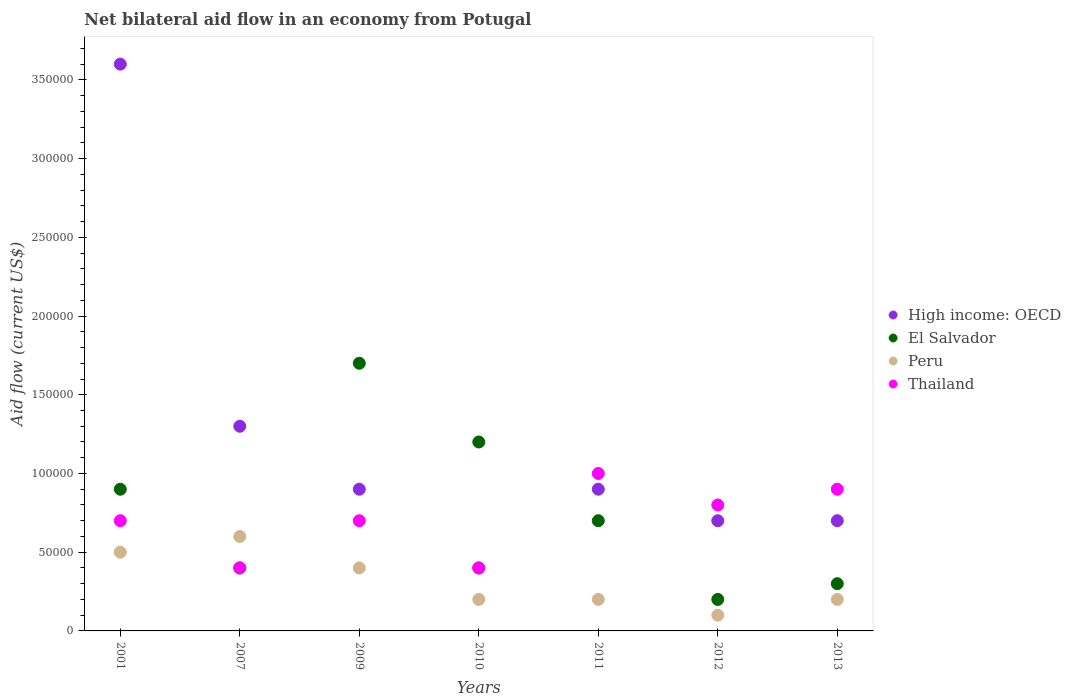How many different coloured dotlines are there?
Ensure brevity in your answer.  4. Is the number of dotlines equal to the number of legend labels?
Provide a succinct answer. Yes. In which year was the net bilateral aid flow in Thailand maximum?
Ensure brevity in your answer.  2011. What is the total net bilateral aid flow in Thailand in the graph?
Give a very brief answer. 4.90e+05. What is the difference between the net bilateral aid flow in El Salvador in 2011 and that in 2012?
Your response must be concise. 5.00e+04. What is the difference between the net bilateral aid flow in El Salvador in 2010 and the net bilateral aid flow in Thailand in 2007?
Your answer should be compact. 8.00e+04. What is the average net bilateral aid flow in Peru per year?
Ensure brevity in your answer.  3.14e+04. In the year 2013, what is the difference between the net bilateral aid flow in High income: OECD and net bilateral aid flow in Peru?
Provide a succinct answer. 5.00e+04. In how many years, is the net bilateral aid flow in El Salvador greater than the average net bilateral aid flow in El Salvador taken over all years?
Ensure brevity in your answer.  3. Does the net bilateral aid flow in El Salvador monotonically increase over the years?
Keep it short and to the point. No. Is the net bilateral aid flow in El Salvador strictly less than the net bilateral aid flow in Thailand over the years?
Offer a very short reply. No. How many years are there in the graph?
Provide a succinct answer. 7. Does the graph contain grids?
Your answer should be compact. No. Where does the legend appear in the graph?
Your answer should be very brief. Center right. What is the title of the graph?
Your answer should be compact. Net bilateral aid flow in an economy from Potugal. What is the label or title of the X-axis?
Give a very brief answer. Years. What is the Aid flow (current US$) of High income: OECD in 2001?
Provide a succinct answer. 3.60e+05. What is the Aid flow (current US$) of El Salvador in 2001?
Give a very brief answer. 9.00e+04. What is the Aid flow (current US$) of Thailand in 2001?
Your answer should be compact. 7.00e+04. What is the Aid flow (current US$) in El Salvador in 2007?
Ensure brevity in your answer.  4.00e+04. What is the Aid flow (current US$) of Thailand in 2007?
Offer a very short reply. 4.00e+04. What is the Aid flow (current US$) of Peru in 2009?
Your answer should be very brief. 4.00e+04. What is the Aid flow (current US$) of Thailand in 2010?
Your response must be concise. 4.00e+04. What is the Aid flow (current US$) in High income: OECD in 2011?
Make the answer very short. 9.00e+04. What is the Aid flow (current US$) in High income: OECD in 2012?
Ensure brevity in your answer.  7.00e+04. What is the Aid flow (current US$) in El Salvador in 2012?
Offer a very short reply. 2.00e+04. What is the Aid flow (current US$) of Peru in 2012?
Offer a very short reply. 10000. What is the Aid flow (current US$) in Thailand in 2012?
Offer a very short reply. 8.00e+04. What is the Aid flow (current US$) of High income: OECD in 2013?
Your answer should be very brief. 7.00e+04. What is the Aid flow (current US$) in Thailand in 2013?
Ensure brevity in your answer.  9.00e+04. Across all years, what is the maximum Aid flow (current US$) in High income: OECD?
Your answer should be very brief. 3.60e+05. Across all years, what is the minimum Aid flow (current US$) of El Salvador?
Offer a very short reply. 2.00e+04. Across all years, what is the minimum Aid flow (current US$) of Thailand?
Your answer should be very brief. 4.00e+04. What is the total Aid flow (current US$) in High income: OECD in the graph?
Ensure brevity in your answer.  8.50e+05. What is the total Aid flow (current US$) of El Salvador in the graph?
Your answer should be compact. 5.40e+05. What is the total Aid flow (current US$) in Thailand in the graph?
Your answer should be very brief. 4.90e+05. What is the difference between the Aid flow (current US$) in High income: OECD in 2001 and that in 2007?
Offer a very short reply. 2.30e+05. What is the difference between the Aid flow (current US$) in El Salvador in 2001 and that in 2007?
Your response must be concise. 5.00e+04. What is the difference between the Aid flow (current US$) of Thailand in 2001 and that in 2007?
Offer a very short reply. 3.00e+04. What is the difference between the Aid flow (current US$) of El Salvador in 2001 and that in 2009?
Offer a very short reply. -8.00e+04. What is the difference between the Aid flow (current US$) of El Salvador in 2001 and that in 2010?
Your answer should be very brief. -3.00e+04. What is the difference between the Aid flow (current US$) in Thailand in 2001 and that in 2010?
Make the answer very short. 3.00e+04. What is the difference between the Aid flow (current US$) in El Salvador in 2001 and that in 2011?
Ensure brevity in your answer.  2.00e+04. What is the difference between the Aid flow (current US$) in Peru in 2001 and that in 2011?
Make the answer very short. 3.00e+04. What is the difference between the Aid flow (current US$) in Thailand in 2001 and that in 2011?
Your answer should be compact. -3.00e+04. What is the difference between the Aid flow (current US$) of El Salvador in 2001 and that in 2012?
Offer a terse response. 7.00e+04. What is the difference between the Aid flow (current US$) of Thailand in 2001 and that in 2012?
Your response must be concise. -10000. What is the difference between the Aid flow (current US$) in High income: OECD in 2001 and that in 2013?
Keep it short and to the point. 2.90e+05. What is the difference between the Aid flow (current US$) of Thailand in 2001 and that in 2013?
Provide a short and direct response. -2.00e+04. What is the difference between the Aid flow (current US$) of High income: OECD in 2007 and that in 2009?
Ensure brevity in your answer.  4.00e+04. What is the difference between the Aid flow (current US$) of Peru in 2007 and that in 2009?
Your answer should be compact. 2.00e+04. What is the difference between the Aid flow (current US$) of El Salvador in 2007 and that in 2010?
Offer a terse response. -8.00e+04. What is the difference between the Aid flow (current US$) in Peru in 2007 and that in 2010?
Your answer should be very brief. 4.00e+04. What is the difference between the Aid flow (current US$) of High income: OECD in 2007 and that in 2011?
Your answer should be compact. 4.00e+04. What is the difference between the Aid flow (current US$) in Peru in 2007 and that in 2011?
Offer a terse response. 4.00e+04. What is the difference between the Aid flow (current US$) in High income: OECD in 2007 and that in 2012?
Make the answer very short. 6.00e+04. What is the difference between the Aid flow (current US$) in Thailand in 2007 and that in 2012?
Keep it short and to the point. -4.00e+04. What is the difference between the Aid flow (current US$) of High income: OECD in 2007 and that in 2013?
Your answer should be very brief. 6.00e+04. What is the difference between the Aid flow (current US$) in El Salvador in 2007 and that in 2013?
Ensure brevity in your answer.  10000. What is the difference between the Aid flow (current US$) in Thailand in 2007 and that in 2013?
Ensure brevity in your answer.  -5.00e+04. What is the difference between the Aid flow (current US$) of El Salvador in 2009 and that in 2010?
Provide a short and direct response. 5.00e+04. What is the difference between the Aid flow (current US$) in High income: OECD in 2009 and that in 2011?
Offer a terse response. 0. What is the difference between the Aid flow (current US$) in High income: OECD in 2009 and that in 2012?
Your answer should be very brief. 2.00e+04. What is the difference between the Aid flow (current US$) of El Salvador in 2009 and that in 2012?
Your response must be concise. 1.50e+05. What is the difference between the Aid flow (current US$) in Thailand in 2009 and that in 2012?
Make the answer very short. -10000. What is the difference between the Aid flow (current US$) of High income: OECD in 2009 and that in 2013?
Offer a very short reply. 2.00e+04. What is the difference between the Aid flow (current US$) of Peru in 2009 and that in 2013?
Offer a very short reply. 2.00e+04. What is the difference between the Aid flow (current US$) in High income: OECD in 2010 and that in 2011?
Your answer should be very brief. -5.00e+04. What is the difference between the Aid flow (current US$) of Thailand in 2010 and that in 2011?
Your answer should be very brief. -6.00e+04. What is the difference between the Aid flow (current US$) in High income: OECD in 2010 and that in 2012?
Your answer should be very brief. -3.00e+04. What is the difference between the Aid flow (current US$) of El Salvador in 2010 and that in 2012?
Give a very brief answer. 1.00e+05. What is the difference between the Aid flow (current US$) in Peru in 2010 and that in 2012?
Offer a terse response. 10000. What is the difference between the Aid flow (current US$) in Thailand in 2010 and that in 2012?
Give a very brief answer. -4.00e+04. What is the difference between the Aid flow (current US$) of High income: OECD in 2010 and that in 2013?
Keep it short and to the point. -3.00e+04. What is the difference between the Aid flow (current US$) of Thailand in 2010 and that in 2013?
Provide a succinct answer. -5.00e+04. What is the difference between the Aid flow (current US$) in High income: OECD in 2011 and that in 2012?
Provide a succinct answer. 2.00e+04. What is the difference between the Aid flow (current US$) in Peru in 2011 and that in 2012?
Provide a short and direct response. 10000. What is the difference between the Aid flow (current US$) of El Salvador in 2011 and that in 2013?
Your answer should be compact. 4.00e+04. What is the difference between the Aid flow (current US$) of High income: OECD in 2012 and that in 2013?
Your answer should be very brief. 0. What is the difference between the Aid flow (current US$) in High income: OECD in 2001 and the Aid flow (current US$) in Peru in 2007?
Give a very brief answer. 3.00e+05. What is the difference between the Aid flow (current US$) of High income: OECD in 2001 and the Aid flow (current US$) of Thailand in 2007?
Make the answer very short. 3.20e+05. What is the difference between the Aid flow (current US$) in High income: OECD in 2001 and the Aid flow (current US$) in El Salvador in 2009?
Your answer should be compact. 1.90e+05. What is the difference between the Aid flow (current US$) in High income: OECD in 2001 and the Aid flow (current US$) in Thailand in 2009?
Give a very brief answer. 2.90e+05. What is the difference between the Aid flow (current US$) in El Salvador in 2001 and the Aid flow (current US$) in Peru in 2009?
Your answer should be compact. 5.00e+04. What is the difference between the Aid flow (current US$) in El Salvador in 2001 and the Aid flow (current US$) in Thailand in 2009?
Ensure brevity in your answer.  2.00e+04. What is the difference between the Aid flow (current US$) of Peru in 2001 and the Aid flow (current US$) of Thailand in 2009?
Offer a terse response. -2.00e+04. What is the difference between the Aid flow (current US$) of High income: OECD in 2001 and the Aid flow (current US$) of Thailand in 2010?
Ensure brevity in your answer.  3.20e+05. What is the difference between the Aid flow (current US$) of High income: OECD in 2001 and the Aid flow (current US$) of El Salvador in 2011?
Make the answer very short. 2.90e+05. What is the difference between the Aid flow (current US$) in High income: OECD in 2001 and the Aid flow (current US$) in Thailand in 2011?
Your answer should be compact. 2.60e+05. What is the difference between the Aid flow (current US$) in El Salvador in 2001 and the Aid flow (current US$) in Peru in 2011?
Provide a succinct answer. 7.00e+04. What is the difference between the Aid flow (current US$) of El Salvador in 2001 and the Aid flow (current US$) of Peru in 2012?
Your response must be concise. 8.00e+04. What is the difference between the Aid flow (current US$) in El Salvador in 2001 and the Aid flow (current US$) in Thailand in 2012?
Keep it short and to the point. 10000. What is the difference between the Aid flow (current US$) of High income: OECD in 2001 and the Aid flow (current US$) of Peru in 2013?
Keep it short and to the point. 3.40e+05. What is the difference between the Aid flow (current US$) of High income: OECD in 2001 and the Aid flow (current US$) of Thailand in 2013?
Keep it short and to the point. 2.70e+05. What is the difference between the Aid flow (current US$) of Peru in 2001 and the Aid flow (current US$) of Thailand in 2013?
Offer a terse response. -4.00e+04. What is the difference between the Aid flow (current US$) of High income: OECD in 2007 and the Aid flow (current US$) of Peru in 2009?
Offer a terse response. 9.00e+04. What is the difference between the Aid flow (current US$) in High income: OECD in 2007 and the Aid flow (current US$) in Thailand in 2009?
Offer a terse response. 6.00e+04. What is the difference between the Aid flow (current US$) in El Salvador in 2007 and the Aid flow (current US$) in Peru in 2009?
Ensure brevity in your answer.  0. What is the difference between the Aid flow (current US$) in High income: OECD in 2007 and the Aid flow (current US$) in El Salvador in 2010?
Your answer should be compact. 10000. What is the difference between the Aid flow (current US$) in El Salvador in 2007 and the Aid flow (current US$) in Thailand in 2010?
Provide a short and direct response. 0. What is the difference between the Aid flow (current US$) in Peru in 2007 and the Aid flow (current US$) in Thailand in 2010?
Provide a short and direct response. 2.00e+04. What is the difference between the Aid flow (current US$) in High income: OECD in 2007 and the Aid flow (current US$) in Peru in 2011?
Provide a succinct answer. 1.10e+05. What is the difference between the Aid flow (current US$) in El Salvador in 2007 and the Aid flow (current US$) in Peru in 2011?
Make the answer very short. 2.00e+04. What is the difference between the Aid flow (current US$) in El Salvador in 2007 and the Aid flow (current US$) in Thailand in 2011?
Ensure brevity in your answer.  -6.00e+04. What is the difference between the Aid flow (current US$) of High income: OECD in 2007 and the Aid flow (current US$) of Peru in 2012?
Keep it short and to the point. 1.20e+05. What is the difference between the Aid flow (current US$) in El Salvador in 2007 and the Aid flow (current US$) in Peru in 2012?
Keep it short and to the point. 3.00e+04. What is the difference between the Aid flow (current US$) of El Salvador in 2007 and the Aid flow (current US$) of Thailand in 2012?
Offer a terse response. -4.00e+04. What is the difference between the Aid flow (current US$) in Peru in 2007 and the Aid flow (current US$) in Thailand in 2012?
Offer a very short reply. -2.00e+04. What is the difference between the Aid flow (current US$) of High income: OECD in 2007 and the Aid flow (current US$) of Peru in 2013?
Keep it short and to the point. 1.10e+05. What is the difference between the Aid flow (current US$) of High income: OECD in 2007 and the Aid flow (current US$) of Thailand in 2013?
Offer a very short reply. 4.00e+04. What is the difference between the Aid flow (current US$) in Peru in 2007 and the Aid flow (current US$) in Thailand in 2013?
Your answer should be compact. -3.00e+04. What is the difference between the Aid flow (current US$) of High income: OECD in 2009 and the Aid flow (current US$) of Peru in 2010?
Offer a very short reply. 7.00e+04. What is the difference between the Aid flow (current US$) in El Salvador in 2009 and the Aid flow (current US$) in Peru in 2010?
Your response must be concise. 1.50e+05. What is the difference between the Aid flow (current US$) of High income: OECD in 2009 and the Aid flow (current US$) of El Salvador in 2011?
Make the answer very short. 2.00e+04. What is the difference between the Aid flow (current US$) of High income: OECD in 2009 and the Aid flow (current US$) of Thailand in 2011?
Offer a very short reply. -10000. What is the difference between the Aid flow (current US$) of El Salvador in 2009 and the Aid flow (current US$) of Thailand in 2011?
Offer a terse response. 7.00e+04. What is the difference between the Aid flow (current US$) of Peru in 2009 and the Aid flow (current US$) of Thailand in 2011?
Your answer should be very brief. -6.00e+04. What is the difference between the Aid flow (current US$) of High income: OECD in 2009 and the Aid flow (current US$) of Peru in 2012?
Your response must be concise. 8.00e+04. What is the difference between the Aid flow (current US$) in High income: OECD in 2009 and the Aid flow (current US$) in Thailand in 2012?
Provide a short and direct response. 10000. What is the difference between the Aid flow (current US$) of El Salvador in 2009 and the Aid flow (current US$) of Peru in 2012?
Your response must be concise. 1.60e+05. What is the difference between the Aid flow (current US$) in High income: OECD in 2009 and the Aid flow (current US$) in El Salvador in 2013?
Your answer should be very brief. 6.00e+04. What is the difference between the Aid flow (current US$) in High income: OECD in 2009 and the Aid flow (current US$) in Peru in 2013?
Provide a short and direct response. 7.00e+04. What is the difference between the Aid flow (current US$) in El Salvador in 2009 and the Aid flow (current US$) in Peru in 2013?
Make the answer very short. 1.50e+05. What is the difference between the Aid flow (current US$) of Peru in 2009 and the Aid flow (current US$) of Thailand in 2013?
Make the answer very short. -5.00e+04. What is the difference between the Aid flow (current US$) of High income: OECD in 2010 and the Aid flow (current US$) of El Salvador in 2011?
Make the answer very short. -3.00e+04. What is the difference between the Aid flow (current US$) of El Salvador in 2010 and the Aid flow (current US$) of Thailand in 2011?
Offer a terse response. 2.00e+04. What is the difference between the Aid flow (current US$) in El Salvador in 2010 and the Aid flow (current US$) in Thailand in 2012?
Ensure brevity in your answer.  4.00e+04. What is the difference between the Aid flow (current US$) in Peru in 2010 and the Aid flow (current US$) in Thailand in 2012?
Keep it short and to the point. -6.00e+04. What is the difference between the Aid flow (current US$) in El Salvador in 2010 and the Aid flow (current US$) in Peru in 2013?
Offer a very short reply. 1.00e+05. What is the difference between the Aid flow (current US$) in El Salvador in 2010 and the Aid flow (current US$) in Thailand in 2013?
Your response must be concise. 3.00e+04. What is the difference between the Aid flow (current US$) in High income: OECD in 2011 and the Aid flow (current US$) in Peru in 2012?
Offer a very short reply. 8.00e+04. What is the difference between the Aid flow (current US$) of High income: OECD in 2011 and the Aid flow (current US$) of Thailand in 2012?
Offer a very short reply. 10000. What is the difference between the Aid flow (current US$) in El Salvador in 2011 and the Aid flow (current US$) in Peru in 2012?
Provide a short and direct response. 6.00e+04. What is the difference between the Aid flow (current US$) in El Salvador in 2011 and the Aid flow (current US$) in Thailand in 2012?
Provide a short and direct response. -10000. What is the difference between the Aid flow (current US$) in High income: OECD in 2011 and the Aid flow (current US$) in El Salvador in 2013?
Offer a very short reply. 6.00e+04. What is the difference between the Aid flow (current US$) in High income: OECD in 2011 and the Aid flow (current US$) in Thailand in 2013?
Your response must be concise. 0. What is the difference between the Aid flow (current US$) of El Salvador in 2012 and the Aid flow (current US$) of Peru in 2013?
Provide a succinct answer. 0. What is the difference between the Aid flow (current US$) in El Salvador in 2012 and the Aid flow (current US$) in Thailand in 2013?
Give a very brief answer. -7.00e+04. What is the average Aid flow (current US$) of High income: OECD per year?
Ensure brevity in your answer.  1.21e+05. What is the average Aid flow (current US$) in El Salvador per year?
Ensure brevity in your answer.  7.71e+04. What is the average Aid flow (current US$) in Peru per year?
Provide a succinct answer. 3.14e+04. In the year 2001, what is the difference between the Aid flow (current US$) of High income: OECD and Aid flow (current US$) of El Salvador?
Your answer should be very brief. 2.70e+05. In the year 2001, what is the difference between the Aid flow (current US$) in High income: OECD and Aid flow (current US$) in Thailand?
Offer a terse response. 2.90e+05. In the year 2001, what is the difference between the Aid flow (current US$) of El Salvador and Aid flow (current US$) of Peru?
Make the answer very short. 4.00e+04. In the year 2001, what is the difference between the Aid flow (current US$) in Peru and Aid flow (current US$) in Thailand?
Provide a short and direct response. -2.00e+04. In the year 2007, what is the difference between the Aid flow (current US$) in High income: OECD and Aid flow (current US$) in El Salvador?
Provide a succinct answer. 9.00e+04. In the year 2007, what is the difference between the Aid flow (current US$) in El Salvador and Aid flow (current US$) in Thailand?
Offer a terse response. 0. In the year 2009, what is the difference between the Aid flow (current US$) in High income: OECD and Aid flow (current US$) in El Salvador?
Make the answer very short. -8.00e+04. In the year 2009, what is the difference between the Aid flow (current US$) of High income: OECD and Aid flow (current US$) of Thailand?
Your answer should be compact. 2.00e+04. In the year 2009, what is the difference between the Aid flow (current US$) in El Salvador and Aid flow (current US$) in Peru?
Give a very brief answer. 1.30e+05. In the year 2009, what is the difference between the Aid flow (current US$) in El Salvador and Aid flow (current US$) in Thailand?
Give a very brief answer. 1.00e+05. In the year 2009, what is the difference between the Aid flow (current US$) of Peru and Aid flow (current US$) of Thailand?
Your response must be concise. -3.00e+04. In the year 2010, what is the difference between the Aid flow (current US$) of High income: OECD and Aid flow (current US$) of El Salvador?
Keep it short and to the point. -8.00e+04. In the year 2010, what is the difference between the Aid flow (current US$) of High income: OECD and Aid flow (current US$) of Thailand?
Give a very brief answer. 0. In the year 2010, what is the difference between the Aid flow (current US$) of Peru and Aid flow (current US$) of Thailand?
Offer a terse response. -2.00e+04. In the year 2011, what is the difference between the Aid flow (current US$) of High income: OECD and Aid flow (current US$) of El Salvador?
Offer a very short reply. 2.00e+04. In the year 2011, what is the difference between the Aid flow (current US$) of High income: OECD and Aid flow (current US$) of Peru?
Your answer should be very brief. 7.00e+04. In the year 2011, what is the difference between the Aid flow (current US$) of High income: OECD and Aid flow (current US$) of Thailand?
Your answer should be compact. -10000. In the year 2011, what is the difference between the Aid flow (current US$) in El Salvador and Aid flow (current US$) in Peru?
Your response must be concise. 5.00e+04. In the year 2011, what is the difference between the Aid flow (current US$) in El Salvador and Aid flow (current US$) in Thailand?
Give a very brief answer. -3.00e+04. In the year 2011, what is the difference between the Aid flow (current US$) in Peru and Aid flow (current US$) in Thailand?
Provide a short and direct response. -8.00e+04. In the year 2012, what is the difference between the Aid flow (current US$) in Peru and Aid flow (current US$) in Thailand?
Offer a very short reply. -7.00e+04. In the year 2013, what is the difference between the Aid flow (current US$) of High income: OECD and Aid flow (current US$) of Thailand?
Keep it short and to the point. -2.00e+04. In the year 2013, what is the difference between the Aid flow (current US$) of El Salvador and Aid flow (current US$) of Peru?
Your response must be concise. 10000. In the year 2013, what is the difference between the Aid flow (current US$) in Peru and Aid flow (current US$) in Thailand?
Your answer should be very brief. -7.00e+04. What is the ratio of the Aid flow (current US$) in High income: OECD in 2001 to that in 2007?
Your answer should be compact. 2.77. What is the ratio of the Aid flow (current US$) of El Salvador in 2001 to that in 2007?
Your response must be concise. 2.25. What is the ratio of the Aid flow (current US$) of Thailand in 2001 to that in 2007?
Offer a very short reply. 1.75. What is the ratio of the Aid flow (current US$) of El Salvador in 2001 to that in 2009?
Offer a terse response. 0.53. What is the ratio of the Aid flow (current US$) in Peru in 2001 to that in 2009?
Give a very brief answer. 1.25. What is the ratio of the Aid flow (current US$) in Thailand in 2001 to that in 2009?
Your response must be concise. 1. What is the ratio of the Aid flow (current US$) in El Salvador in 2001 to that in 2010?
Provide a succinct answer. 0.75. What is the ratio of the Aid flow (current US$) of Peru in 2001 to that in 2010?
Provide a short and direct response. 2.5. What is the ratio of the Aid flow (current US$) in Thailand in 2001 to that in 2011?
Ensure brevity in your answer.  0.7. What is the ratio of the Aid flow (current US$) in High income: OECD in 2001 to that in 2012?
Give a very brief answer. 5.14. What is the ratio of the Aid flow (current US$) of Thailand in 2001 to that in 2012?
Provide a succinct answer. 0.88. What is the ratio of the Aid flow (current US$) in High income: OECD in 2001 to that in 2013?
Provide a short and direct response. 5.14. What is the ratio of the Aid flow (current US$) of El Salvador in 2001 to that in 2013?
Your answer should be very brief. 3. What is the ratio of the Aid flow (current US$) in Peru in 2001 to that in 2013?
Your answer should be compact. 2.5. What is the ratio of the Aid flow (current US$) of High income: OECD in 2007 to that in 2009?
Provide a succinct answer. 1.44. What is the ratio of the Aid flow (current US$) in El Salvador in 2007 to that in 2009?
Your answer should be compact. 0.24. What is the ratio of the Aid flow (current US$) of Peru in 2007 to that in 2009?
Give a very brief answer. 1.5. What is the ratio of the Aid flow (current US$) of High income: OECD in 2007 to that in 2010?
Your answer should be very brief. 3.25. What is the ratio of the Aid flow (current US$) of Peru in 2007 to that in 2010?
Your answer should be very brief. 3. What is the ratio of the Aid flow (current US$) in High income: OECD in 2007 to that in 2011?
Ensure brevity in your answer.  1.44. What is the ratio of the Aid flow (current US$) of El Salvador in 2007 to that in 2011?
Your answer should be compact. 0.57. What is the ratio of the Aid flow (current US$) in Peru in 2007 to that in 2011?
Your response must be concise. 3. What is the ratio of the Aid flow (current US$) of Thailand in 2007 to that in 2011?
Provide a succinct answer. 0.4. What is the ratio of the Aid flow (current US$) in High income: OECD in 2007 to that in 2012?
Give a very brief answer. 1.86. What is the ratio of the Aid flow (current US$) of High income: OECD in 2007 to that in 2013?
Ensure brevity in your answer.  1.86. What is the ratio of the Aid flow (current US$) of El Salvador in 2007 to that in 2013?
Offer a very short reply. 1.33. What is the ratio of the Aid flow (current US$) in Thailand in 2007 to that in 2013?
Provide a short and direct response. 0.44. What is the ratio of the Aid flow (current US$) of High income: OECD in 2009 to that in 2010?
Give a very brief answer. 2.25. What is the ratio of the Aid flow (current US$) of El Salvador in 2009 to that in 2010?
Ensure brevity in your answer.  1.42. What is the ratio of the Aid flow (current US$) of Thailand in 2009 to that in 2010?
Give a very brief answer. 1.75. What is the ratio of the Aid flow (current US$) of El Salvador in 2009 to that in 2011?
Keep it short and to the point. 2.43. What is the ratio of the Aid flow (current US$) of High income: OECD in 2009 to that in 2012?
Your answer should be very brief. 1.29. What is the ratio of the Aid flow (current US$) of El Salvador in 2009 to that in 2012?
Keep it short and to the point. 8.5. What is the ratio of the Aid flow (current US$) in Peru in 2009 to that in 2012?
Offer a terse response. 4. What is the ratio of the Aid flow (current US$) of El Salvador in 2009 to that in 2013?
Make the answer very short. 5.67. What is the ratio of the Aid flow (current US$) of Peru in 2009 to that in 2013?
Provide a succinct answer. 2. What is the ratio of the Aid flow (current US$) in Thailand in 2009 to that in 2013?
Your answer should be compact. 0.78. What is the ratio of the Aid flow (current US$) in High income: OECD in 2010 to that in 2011?
Keep it short and to the point. 0.44. What is the ratio of the Aid flow (current US$) in El Salvador in 2010 to that in 2011?
Your response must be concise. 1.71. What is the ratio of the Aid flow (current US$) in Peru in 2010 to that in 2012?
Keep it short and to the point. 2. What is the ratio of the Aid flow (current US$) in Thailand in 2010 to that in 2012?
Provide a succinct answer. 0.5. What is the ratio of the Aid flow (current US$) of Peru in 2010 to that in 2013?
Provide a short and direct response. 1. What is the ratio of the Aid flow (current US$) of Thailand in 2010 to that in 2013?
Give a very brief answer. 0.44. What is the ratio of the Aid flow (current US$) in High income: OECD in 2011 to that in 2012?
Make the answer very short. 1.29. What is the ratio of the Aid flow (current US$) in El Salvador in 2011 to that in 2013?
Your answer should be very brief. 2.33. What is the ratio of the Aid flow (current US$) in Peru in 2011 to that in 2013?
Your answer should be very brief. 1. What is the ratio of the Aid flow (current US$) of El Salvador in 2012 to that in 2013?
Your answer should be very brief. 0.67. What is the ratio of the Aid flow (current US$) of Peru in 2012 to that in 2013?
Provide a succinct answer. 0.5. What is the ratio of the Aid flow (current US$) of Thailand in 2012 to that in 2013?
Your answer should be compact. 0.89. What is the difference between the highest and the second highest Aid flow (current US$) of Peru?
Make the answer very short. 10000. What is the difference between the highest and the lowest Aid flow (current US$) of El Salvador?
Ensure brevity in your answer.  1.50e+05. What is the difference between the highest and the lowest Aid flow (current US$) in Thailand?
Ensure brevity in your answer.  6.00e+04. 